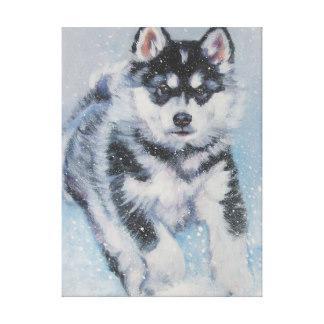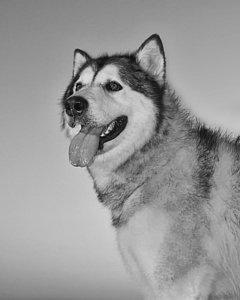The first image is the image on the left, the second image is the image on the right. For the images displayed, is the sentence "In one image the head and paws of an Alaskan Malamute dog are depicted." factually correct? Answer yes or no. Yes. 